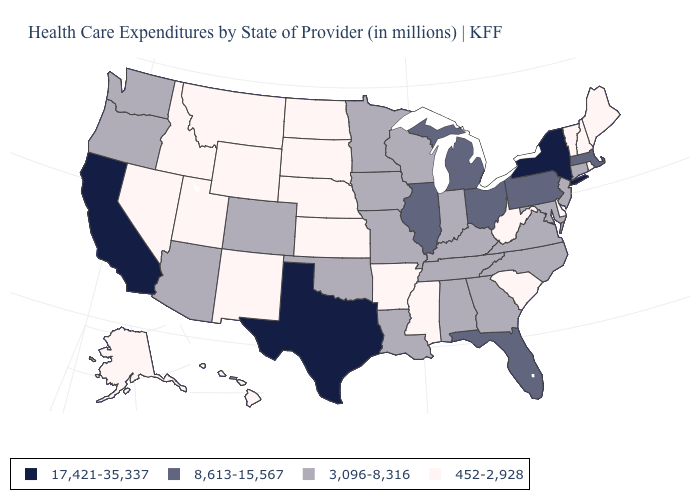Among the states that border Georgia , does South Carolina have the lowest value?
Quick response, please. Yes. What is the value of Wyoming?
Answer briefly. 452-2,928. What is the value of Delaware?
Keep it brief. 452-2,928. Among the states that border Oregon , does Washington have the highest value?
Concise answer only. No. What is the highest value in states that border Michigan?
Be succinct. 8,613-15,567. Among the states that border Alabama , does Florida have the highest value?
Quick response, please. Yes. What is the value of Vermont?
Answer briefly. 452-2,928. What is the value of North Dakota?
Be succinct. 452-2,928. Name the states that have a value in the range 3,096-8,316?
Concise answer only. Alabama, Arizona, Colorado, Connecticut, Georgia, Indiana, Iowa, Kentucky, Louisiana, Maryland, Minnesota, Missouri, New Jersey, North Carolina, Oklahoma, Oregon, Tennessee, Virginia, Washington, Wisconsin. Name the states that have a value in the range 8,613-15,567?
Be succinct. Florida, Illinois, Massachusetts, Michigan, Ohio, Pennsylvania. Among the states that border Tennessee , which have the lowest value?
Be succinct. Arkansas, Mississippi. Does the map have missing data?
Be succinct. No. How many symbols are there in the legend?
Give a very brief answer. 4. What is the lowest value in the USA?
Keep it brief. 452-2,928. How many symbols are there in the legend?
Write a very short answer. 4. 